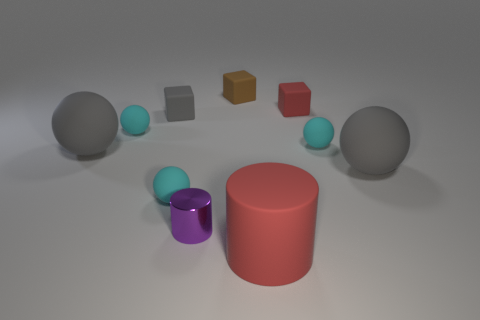There is a red block that is the same size as the gray block; what material is it?
Offer a very short reply. Rubber. What material is the big red object right of the large rubber ball that is to the left of the large gray rubber object that is on the right side of the large matte cylinder?
Ensure brevity in your answer.  Rubber. What is the color of the tiny cylinder?
Make the answer very short. Purple. What number of large objects are matte things or cyan balls?
Make the answer very short. 3. What material is the small object that is the same color as the matte cylinder?
Your response must be concise. Rubber. Do the tiny sphere that is to the right of the big cylinder and the red thing that is in front of the small purple shiny cylinder have the same material?
Ensure brevity in your answer.  Yes. Are any cyan spheres visible?
Keep it short and to the point. Yes. Are there more balls behind the gray cube than tiny cyan rubber objects that are on the left side of the small shiny thing?
Your response must be concise. No. There is another thing that is the same shape as the large red rubber object; what is its material?
Your answer should be compact. Metal. Are there any other things that are the same size as the brown rubber thing?
Give a very brief answer. Yes. 